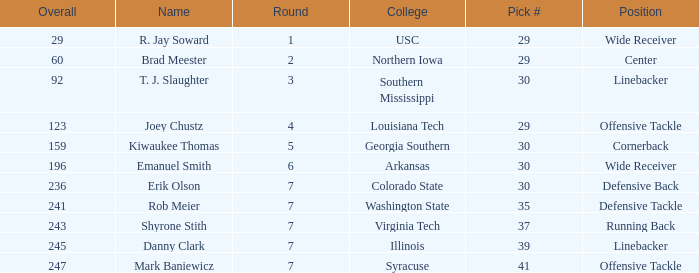What is the Position with a round 3 pick for r. jay soward? Wide Receiver. 